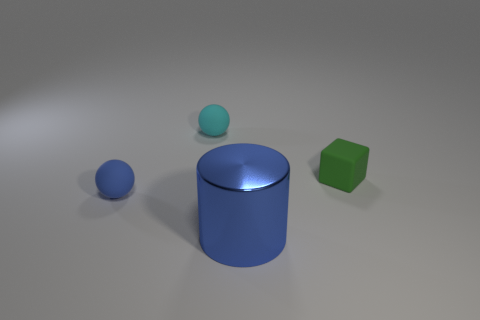Add 1 big shiny things. How many objects exist? 5 Subtract all cubes. How many objects are left? 3 Add 2 red rubber spheres. How many red rubber spheres exist? 2 Subtract 0 green spheres. How many objects are left? 4 Subtract all small things. Subtract all blue cylinders. How many objects are left? 0 Add 1 tiny rubber cubes. How many tiny rubber cubes are left? 2 